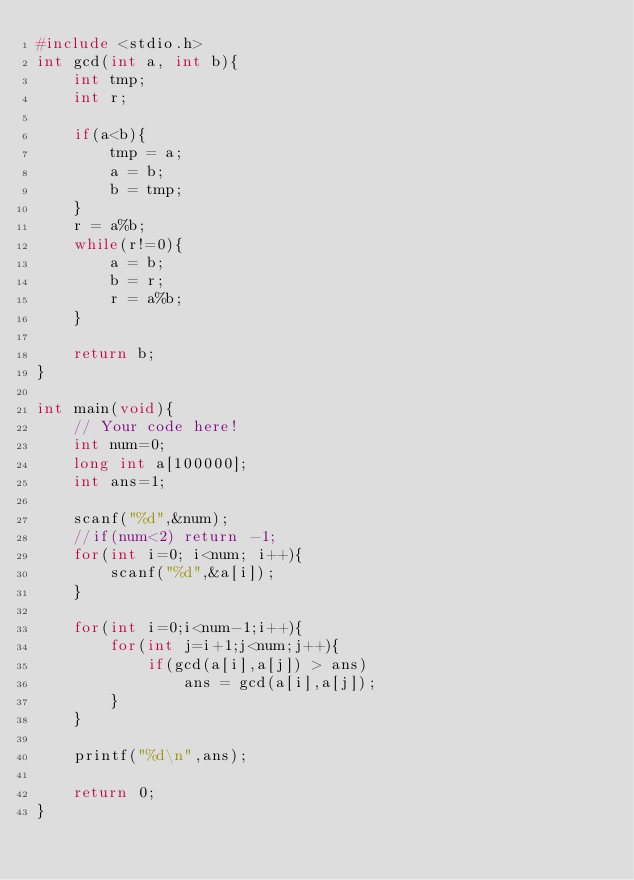Convert code to text. <code><loc_0><loc_0><loc_500><loc_500><_C_>#include <stdio.h>
int gcd(int a, int b){
    int tmp;
    int r;
    
    if(a<b){
        tmp = a;
        a = b;
        b = tmp;
    }
    r = a%b;
    while(r!=0){
        a = b;
        b = r;
        r = a%b;
    }
    
    return b;
}

int main(void){
    // Your code here!
    int num=0;
    long int a[100000];
    int ans=1;
    
    scanf("%d",&num);
    //if(num<2) return -1;
    for(int i=0; i<num; i++){
        scanf("%d",&a[i]);
    }
    
    for(int i=0;i<num-1;i++){
        for(int j=i+1;j<num;j++){
            if(gcd(a[i],a[j]) > ans)
                ans = gcd(a[i],a[j]);
        }
    }

    printf("%d\n",ans);

    return 0;
}</code> 